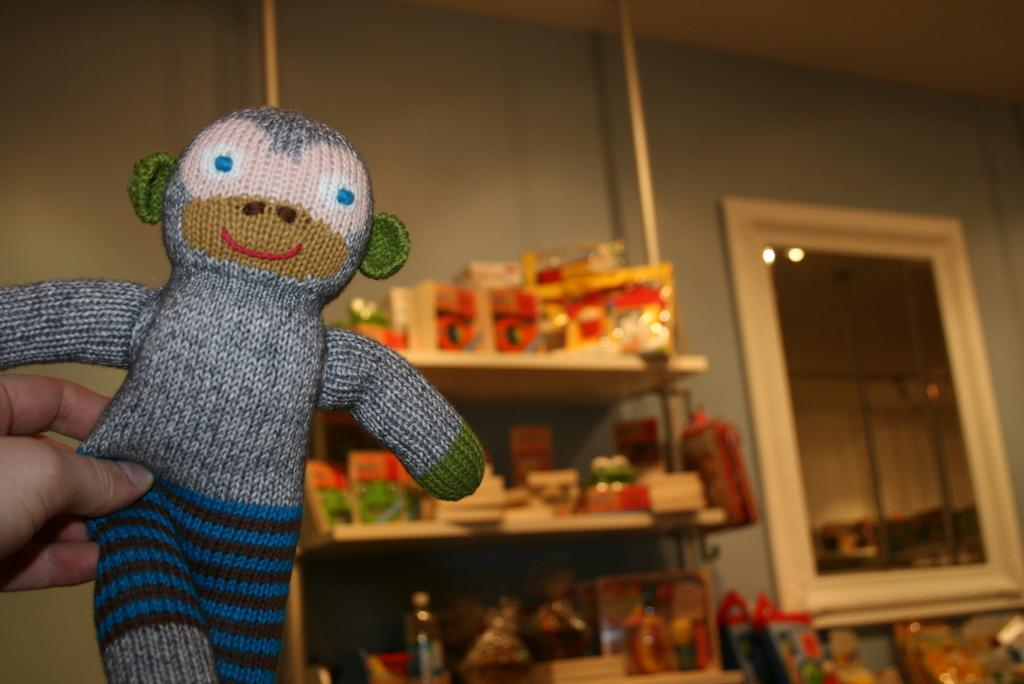What is on the rack in the image? There is a rack containing toys in the image. Can you describe the hand visible on the left side of the image? A hand is visible on the left side of the image, holding a toy. What is on the right side of the image? There is a mirror on the right side of the image. What type of skin can be seen on the knee of the person in the image? There is no person visible in the image, and therefore no knee or skin can be observed. What is the tin content of the toys in the image? The toys in the image are not described in terms of their tin content, so it cannot be determined from the image. 